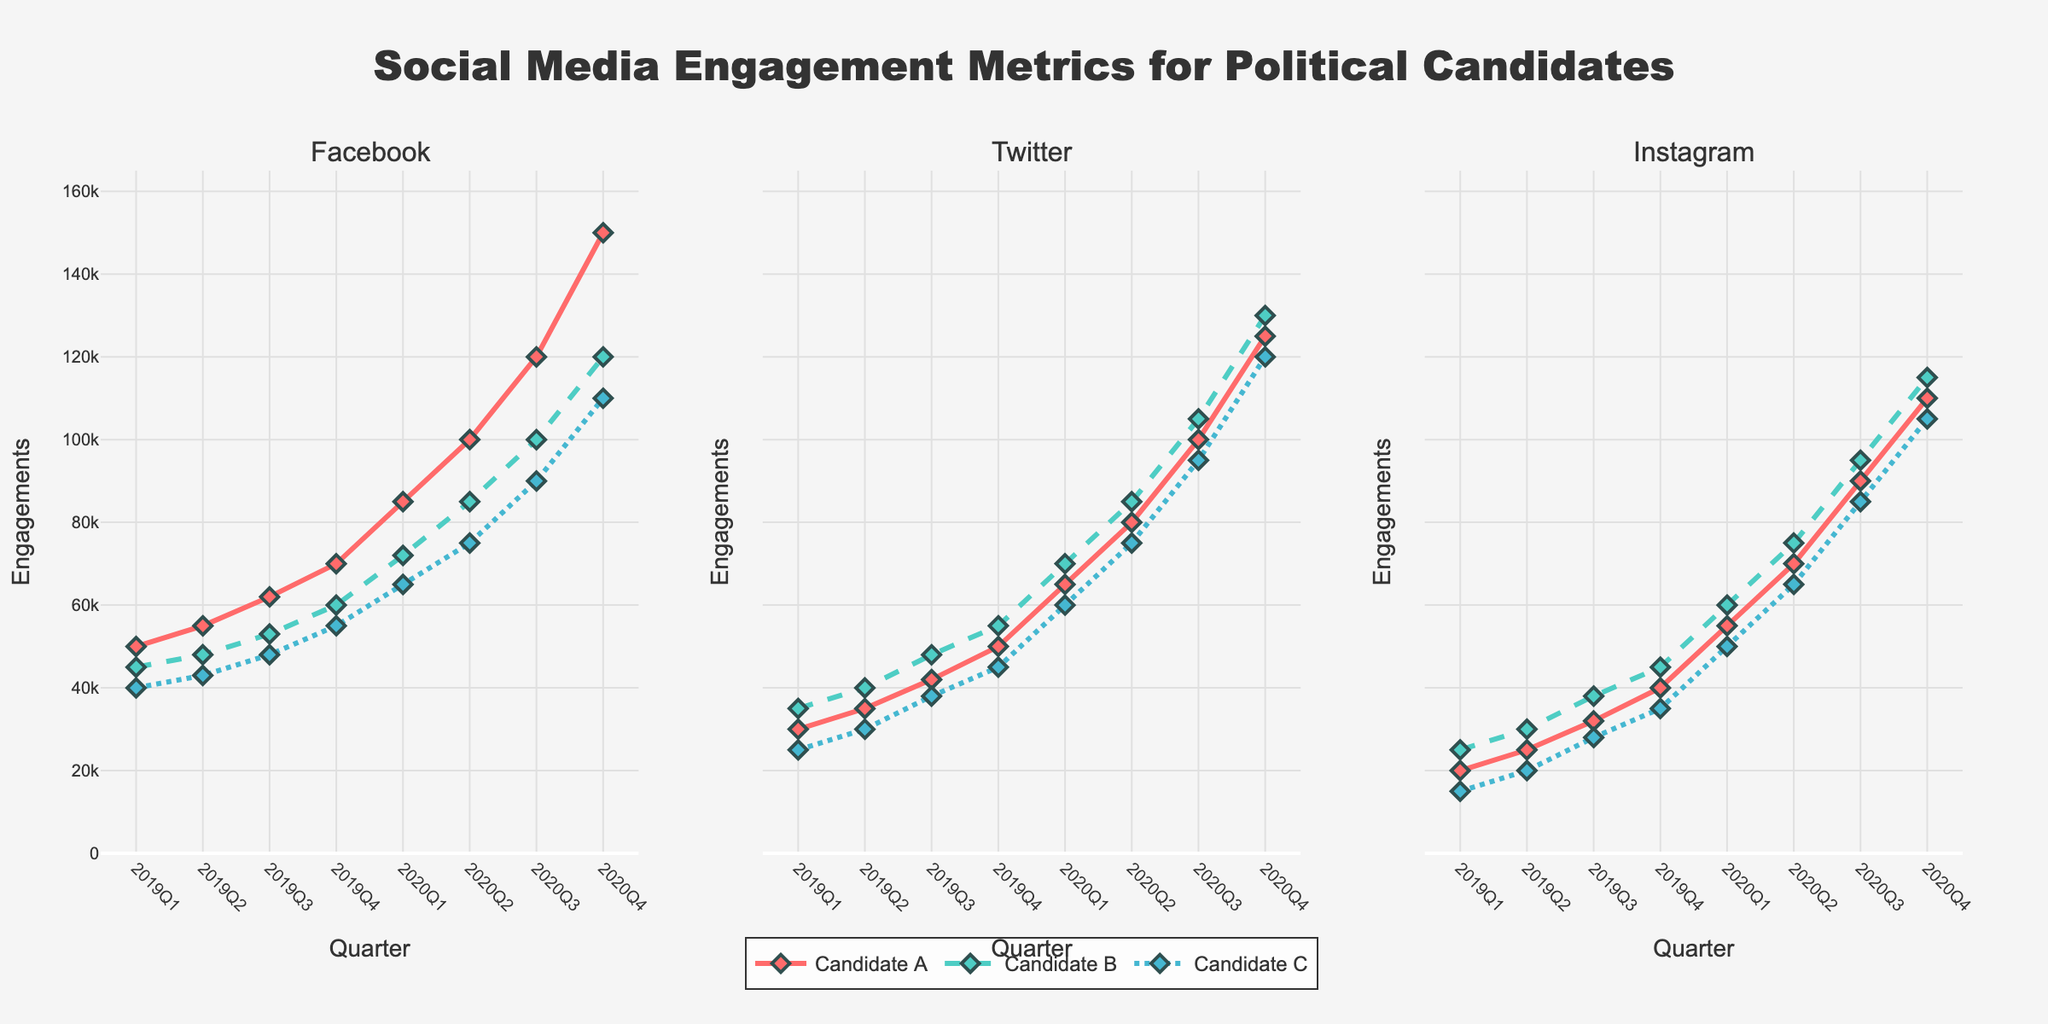Which candidate had the highest engagement on Instagram in 2020Q4? Look at the Instagram subplot and check the highest point on the line chart for 2020Q4. Candidate A reaches 110,000, Candidate B reaches 115,000, and Candidate C reaches 105,000. Candidate B is the highest.
Answer: Candidate B Which platform did Candidate A witness the most significant increase in engagement between 2019Q1 and 2020Q4? Look at Candidate A's lines in the chart. Calculate the difference between 2019Q1 and 2020Q4 for Facebook (150,000 - 50,000), Twitter (125,000 - 30,000), and Instagram (110,000 - 20,000). Facebook increase is 100,000, Twitter increase is 95,000, and Instagram increase is 90,000.
Answer: Facebook By how much did Candidate C's engagement on Twitter increase from 2020Q1 to 2020Q4? Look at the Twitter subplot for Candidate C. The engagement increases from 60,000 in 2020Q1 to 120,000 in 2020Q4. Calculate the difference 120,000 - 60,000.
Answer: 60,000 Whose engagement on Facebook was the lowest in 2020Q3, and what was the value? Refer to the Facebook subplot and compare the points at 2020Q3 for all candidates. Candidate C has the lowest engagement with 90,000.
Answer: Candidate C, 90,000 What was the overall trend for Candidate B's engagement on Facebook from 2019Q1 to 2020Q4? Look at Candidate B's line on the Facebook subplot. It steadily increases from 45,000 in 2019Q1 to 120,000 in 2020Q4.
Answer: Increasing Comparing Candidate A and Candidate B, who had a higher engagement on Twitter in 2019Q3? Refer to the Twitter subplot and compare the values for Candidate A and Candidate B at 2019Q3. Candidate A has 42,000, and Candidate B has 48,000. Candidate B has a higher engagement.
Answer: Candidate B What is the sum of Candidate A's engagements across all platforms in 2019Q4? Add the engagement values from Facebook (70,000), Twitter (50,000), and Instagram (40,000) for Candidate A in 2019Q4. Sum is 70,000 + 50,000 + 40,000.
Answer: 160,000 On which platform did Candidate C make the smallest gain from 2019Q1 to 2020Q4? Calculate the differences for Candidate C on Facebook (110,000 - 40,000), Twitter (120,000 - 25,000), and Instagram (105,000 - 15,000). Gains are 70,000, 95,000, and 90,000 respectively. Facebook has the smallest gain.
Answer: Facebook 